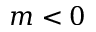<formula> <loc_0><loc_0><loc_500><loc_500>m < 0</formula> 